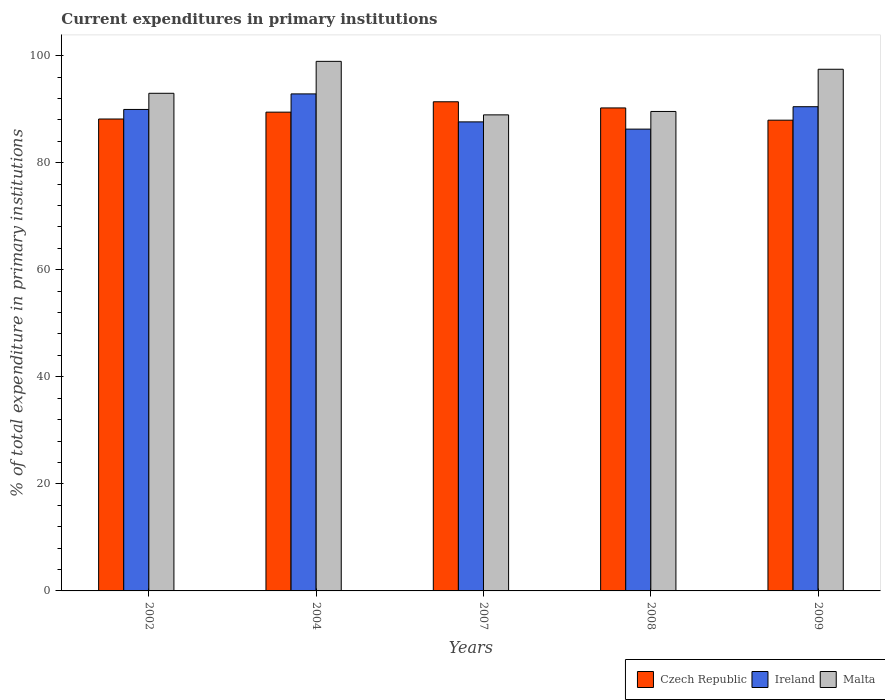How many groups of bars are there?
Give a very brief answer. 5. What is the current expenditures in primary institutions in Ireland in 2004?
Offer a terse response. 92.85. Across all years, what is the maximum current expenditures in primary institutions in Ireland?
Keep it short and to the point. 92.85. Across all years, what is the minimum current expenditures in primary institutions in Ireland?
Ensure brevity in your answer.  86.27. What is the total current expenditures in primary institutions in Ireland in the graph?
Ensure brevity in your answer.  447.14. What is the difference between the current expenditures in primary institutions in Ireland in 2002 and that in 2007?
Your response must be concise. 2.32. What is the difference between the current expenditures in primary institutions in Czech Republic in 2007 and the current expenditures in primary institutions in Malta in 2008?
Keep it short and to the point. 1.81. What is the average current expenditures in primary institutions in Malta per year?
Offer a very short reply. 93.57. In the year 2002, what is the difference between the current expenditures in primary institutions in Malta and current expenditures in primary institutions in Ireland?
Your answer should be compact. 3.02. What is the ratio of the current expenditures in primary institutions in Czech Republic in 2007 to that in 2008?
Provide a short and direct response. 1.01. Is the current expenditures in primary institutions in Czech Republic in 2002 less than that in 2009?
Keep it short and to the point. No. What is the difference between the highest and the second highest current expenditures in primary institutions in Czech Republic?
Your answer should be compact. 1.15. What is the difference between the highest and the lowest current expenditures in primary institutions in Malta?
Offer a very short reply. 10. Is the sum of the current expenditures in primary institutions in Czech Republic in 2004 and 2008 greater than the maximum current expenditures in primary institutions in Malta across all years?
Keep it short and to the point. Yes. What does the 2nd bar from the left in 2007 represents?
Make the answer very short. Ireland. What does the 3rd bar from the right in 2009 represents?
Make the answer very short. Czech Republic. Is it the case that in every year, the sum of the current expenditures in primary institutions in Ireland and current expenditures in primary institutions in Czech Republic is greater than the current expenditures in primary institutions in Malta?
Make the answer very short. Yes. Are all the bars in the graph horizontal?
Ensure brevity in your answer.  No. Are the values on the major ticks of Y-axis written in scientific E-notation?
Your answer should be compact. No. How many legend labels are there?
Give a very brief answer. 3. How are the legend labels stacked?
Provide a short and direct response. Horizontal. What is the title of the graph?
Your answer should be very brief. Current expenditures in primary institutions. Does "Isle of Man" appear as one of the legend labels in the graph?
Provide a short and direct response. No. What is the label or title of the X-axis?
Ensure brevity in your answer.  Years. What is the label or title of the Y-axis?
Provide a succinct answer. % of total expenditure in primary institutions. What is the % of total expenditure in primary institutions in Czech Republic in 2002?
Keep it short and to the point. 88.16. What is the % of total expenditure in primary institutions in Ireland in 2002?
Offer a very short reply. 89.94. What is the % of total expenditure in primary institutions in Malta in 2002?
Make the answer very short. 92.96. What is the % of total expenditure in primary institutions of Czech Republic in 2004?
Provide a succinct answer. 89.44. What is the % of total expenditure in primary institutions in Ireland in 2004?
Offer a terse response. 92.85. What is the % of total expenditure in primary institutions in Malta in 2004?
Offer a very short reply. 98.93. What is the % of total expenditure in primary institutions of Czech Republic in 2007?
Provide a short and direct response. 91.38. What is the % of total expenditure in primary institutions of Ireland in 2007?
Provide a short and direct response. 87.62. What is the % of total expenditure in primary institutions in Malta in 2007?
Provide a succinct answer. 88.93. What is the % of total expenditure in primary institutions of Czech Republic in 2008?
Your answer should be very brief. 90.23. What is the % of total expenditure in primary institutions in Ireland in 2008?
Your answer should be very brief. 86.27. What is the % of total expenditure in primary institutions of Malta in 2008?
Offer a very short reply. 89.57. What is the % of total expenditure in primary institutions in Czech Republic in 2009?
Make the answer very short. 87.94. What is the % of total expenditure in primary institutions of Ireland in 2009?
Provide a succinct answer. 90.46. What is the % of total expenditure in primary institutions in Malta in 2009?
Make the answer very short. 97.45. Across all years, what is the maximum % of total expenditure in primary institutions in Czech Republic?
Offer a very short reply. 91.38. Across all years, what is the maximum % of total expenditure in primary institutions of Ireland?
Keep it short and to the point. 92.85. Across all years, what is the maximum % of total expenditure in primary institutions in Malta?
Make the answer very short. 98.93. Across all years, what is the minimum % of total expenditure in primary institutions in Czech Republic?
Offer a very short reply. 87.94. Across all years, what is the minimum % of total expenditure in primary institutions of Ireland?
Make the answer very short. 86.27. Across all years, what is the minimum % of total expenditure in primary institutions of Malta?
Offer a terse response. 88.93. What is the total % of total expenditure in primary institutions in Czech Republic in the graph?
Provide a succinct answer. 447.15. What is the total % of total expenditure in primary institutions of Ireland in the graph?
Provide a succinct answer. 447.14. What is the total % of total expenditure in primary institutions of Malta in the graph?
Provide a short and direct response. 467.85. What is the difference between the % of total expenditure in primary institutions of Czech Republic in 2002 and that in 2004?
Offer a terse response. -1.28. What is the difference between the % of total expenditure in primary institutions of Ireland in 2002 and that in 2004?
Provide a succinct answer. -2.9. What is the difference between the % of total expenditure in primary institutions in Malta in 2002 and that in 2004?
Ensure brevity in your answer.  -5.96. What is the difference between the % of total expenditure in primary institutions of Czech Republic in 2002 and that in 2007?
Your response must be concise. -3.22. What is the difference between the % of total expenditure in primary institutions in Ireland in 2002 and that in 2007?
Provide a succinct answer. 2.32. What is the difference between the % of total expenditure in primary institutions in Malta in 2002 and that in 2007?
Your answer should be compact. 4.03. What is the difference between the % of total expenditure in primary institutions in Czech Republic in 2002 and that in 2008?
Your answer should be very brief. -2.07. What is the difference between the % of total expenditure in primary institutions in Ireland in 2002 and that in 2008?
Your answer should be compact. 3.68. What is the difference between the % of total expenditure in primary institutions in Malta in 2002 and that in 2008?
Give a very brief answer. 3.39. What is the difference between the % of total expenditure in primary institutions in Czech Republic in 2002 and that in 2009?
Ensure brevity in your answer.  0.22. What is the difference between the % of total expenditure in primary institutions of Ireland in 2002 and that in 2009?
Keep it short and to the point. -0.51. What is the difference between the % of total expenditure in primary institutions in Malta in 2002 and that in 2009?
Give a very brief answer. -4.49. What is the difference between the % of total expenditure in primary institutions of Czech Republic in 2004 and that in 2007?
Provide a short and direct response. -1.94. What is the difference between the % of total expenditure in primary institutions of Ireland in 2004 and that in 2007?
Your answer should be compact. 5.23. What is the difference between the % of total expenditure in primary institutions in Malta in 2004 and that in 2007?
Make the answer very short. 10. What is the difference between the % of total expenditure in primary institutions of Czech Republic in 2004 and that in 2008?
Offer a terse response. -0.79. What is the difference between the % of total expenditure in primary institutions of Ireland in 2004 and that in 2008?
Provide a short and direct response. 6.58. What is the difference between the % of total expenditure in primary institutions in Malta in 2004 and that in 2008?
Give a very brief answer. 9.36. What is the difference between the % of total expenditure in primary institutions in Czech Republic in 2004 and that in 2009?
Your response must be concise. 1.5. What is the difference between the % of total expenditure in primary institutions in Ireland in 2004 and that in 2009?
Your answer should be very brief. 2.39. What is the difference between the % of total expenditure in primary institutions of Malta in 2004 and that in 2009?
Ensure brevity in your answer.  1.48. What is the difference between the % of total expenditure in primary institutions in Czech Republic in 2007 and that in 2008?
Offer a terse response. 1.15. What is the difference between the % of total expenditure in primary institutions of Ireland in 2007 and that in 2008?
Provide a succinct answer. 1.35. What is the difference between the % of total expenditure in primary institutions of Malta in 2007 and that in 2008?
Offer a very short reply. -0.64. What is the difference between the % of total expenditure in primary institutions in Czech Republic in 2007 and that in 2009?
Offer a very short reply. 3.44. What is the difference between the % of total expenditure in primary institutions of Ireland in 2007 and that in 2009?
Offer a very short reply. -2.84. What is the difference between the % of total expenditure in primary institutions of Malta in 2007 and that in 2009?
Provide a succinct answer. -8.52. What is the difference between the % of total expenditure in primary institutions in Czech Republic in 2008 and that in 2009?
Your answer should be compact. 2.29. What is the difference between the % of total expenditure in primary institutions in Ireland in 2008 and that in 2009?
Keep it short and to the point. -4.19. What is the difference between the % of total expenditure in primary institutions in Malta in 2008 and that in 2009?
Offer a terse response. -7.88. What is the difference between the % of total expenditure in primary institutions of Czech Republic in 2002 and the % of total expenditure in primary institutions of Ireland in 2004?
Offer a very short reply. -4.69. What is the difference between the % of total expenditure in primary institutions in Czech Republic in 2002 and the % of total expenditure in primary institutions in Malta in 2004?
Provide a succinct answer. -10.77. What is the difference between the % of total expenditure in primary institutions of Ireland in 2002 and the % of total expenditure in primary institutions of Malta in 2004?
Provide a short and direct response. -8.98. What is the difference between the % of total expenditure in primary institutions in Czech Republic in 2002 and the % of total expenditure in primary institutions in Ireland in 2007?
Ensure brevity in your answer.  0.54. What is the difference between the % of total expenditure in primary institutions of Czech Republic in 2002 and the % of total expenditure in primary institutions of Malta in 2007?
Provide a short and direct response. -0.77. What is the difference between the % of total expenditure in primary institutions in Ireland in 2002 and the % of total expenditure in primary institutions in Malta in 2007?
Offer a very short reply. 1.01. What is the difference between the % of total expenditure in primary institutions of Czech Republic in 2002 and the % of total expenditure in primary institutions of Ireland in 2008?
Provide a short and direct response. 1.89. What is the difference between the % of total expenditure in primary institutions in Czech Republic in 2002 and the % of total expenditure in primary institutions in Malta in 2008?
Your answer should be very brief. -1.41. What is the difference between the % of total expenditure in primary institutions in Ireland in 2002 and the % of total expenditure in primary institutions in Malta in 2008?
Provide a short and direct response. 0.38. What is the difference between the % of total expenditure in primary institutions of Czech Republic in 2002 and the % of total expenditure in primary institutions of Ireland in 2009?
Give a very brief answer. -2.3. What is the difference between the % of total expenditure in primary institutions in Czech Republic in 2002 and the % of total expenditure in primary institutions in Malta in 2009?
Give a very brief answer. -9.29. What is the difference between the % of total expenditure in primary institutions in Ireland in 2002 and the % of total expenditure in primary institutions in Malta in 2009?
Provide a short and direct response. -7.51. What is the difference between the % of total expenditure in primary institutions in Czech Republic in 2004 and the % of total expenditure in primary institutions in Ireland in 2007?
Offer a terse response. 1.82. What is the difference between the % of total expenditure in primary institutions in Czech Republic in 2004 and the % of total expenditure in primary institutions in Malta in 2007?
Keep it short and to the point. 0.51. What is the difference between the % of total expenditure in primary institutions of Ireland in 2004 and the % of total expenditure in primary institutions of Malta in 2007?
Offer a very short reply. 3.92. What is the difference between the % of total expenditure in primary institutions of Czech Republic in 2004 and the % of total expenditure in primary institutions of Ireland in 2008?
Keep it short and to the point. 3.17. What is the difference between the % of total expenditure in primary institutions in Czech Republic in 2004 and the % of total expenditure in primary institutions in Malta in 2008?
Your answer should be very brief. -0.13. What is the difference between the % of total expenditure in primary institutions of Ireland in 2004 and the % of total expenditure in primary institutions of Malta in 2008?
Your answer should be very brief. 3.28. What is the difference between the % of total expenditure in primary institutions of Czech Republic in 2004 and the % of total expenditure in primary institutions of Ireland in 2009?
Your answer should be very brief. -1.02. What is the difference between the % of total expenditure in primary institutions in Czech Republic in 2004 and the % of total expenditure in primary institutions in Malta in 2009?
Your response must be concise. -8.01. What is the difference between the % of total expenditure in primary institutions of Ireland in 2004 and the % of total expenditure in primary institutions of Malta in 2009?
Offer a terse response. -4.6. What is the difference between the % of total expenditure in primary institutions in Czech Republic in 2007 and the % of total expenditure in primary institutions in Ireland in 2008?
Provide a short and direct response. 5.11. What is the difference between the % of total expenditure in primary institutions of Czech Republic in 2007 and the % of total expenditure in primary institutions of Malta in 2008?
Your response must be concise. 1.81. What is the difference between the % of total expenditure in primary institutions in Ireland in 2007 and the % of total expenditure in primary institutions in Malta in 2008?
Ensure brevity in your answer.  -1.95. What is the difference between the % of total expenditure in primary institutions of Czech Republic in 2007 and the % of total expenditure in primary institutions of Ireland in 2009?
Your answer should be very brief. 0.92. What is the difference between the % of total expenditure in primary institutions of Czech Republic in 2007 and the % of total expenditure in primary institutions of Malta in 2009?
Your answer should be compact. -6.07. What is the difference between the % of total expenditure in primary institutions of Ireland in 2007 and the % of total expenditure in primary institutions of Malta in 2009?
Ensure brevity in your answer.  -9.83. What is the difference between the % of total expenditure in primary institutions in Czech Republic in 2008 and the % of total expenditure in primary institutions in Ireland in 2009?
Make the answer very short. -0.23. What is the difference between the % of total expenditure in primary institutions in Czech Republic in 2008 and the % of total expenditure in primary institutions in Malta in 2009?
Ensure brevity in your answer.  -7.22. What is the difference between the % of total expenditure in primary institutions of Ireland in 2008 and the % of total expenditure in primary institutions of Malta in 2009?
Your response must be concise. -11.18. What is the average % of total expenditure in primary institutions in Czech Republic per year?
Your response must be concise. 89.43. What is the average % of total expenditure in primary institutions of Ireland per year?
Your answer should be very brief. 89.43. What is the average % of total expenditure in primary institutions in Malta per year?
Your answer should be compact. 93.57. In the year 2002, what is the difference between the % of total expenditure in primary institutions of Czech Republic and % of total expenditure in primary institutions of Ireland?
Your answer should be very brief. -1.79. In the year 2002, what is the difference between the % of total expenditure in primary institutions of Czech Republic and % of total expenditure in primary institutions of Malta?
Offer a very short reply. -4.8. In the year 2002, what is the difference between the % of total expenditure in primary institutions of Ireland and % of total expenditure in primary institutions of Malta?
Offer a very short reply. -3.02. In the year 2004, what is the difference between the % of total expenditure in primary institutions of Czech Republic and % of total expenditure in primary institutions of Ireland?
Offer a terse response. -3.41. In the year 2004, what is the difference between the % of total expenditure in primary institutions of Czech Republic and % of total expenditure in primary institutions of Malta?
Make the answer very short. -9.49. In the year 2004, what is the difference between the % of total expenditure in primary institutions in Ireland and % of total expenditure in primary institutions in Malta?
Your answer should be compact. -6.08. In the year 2007, what is the difference between the % of total expenditure in primary institutions in Czech Republic and % of total expenditure in primary institutions in Ireland?
Make the answer very short. 3.76. In the year 2007, what is the difference between the % of total expenditure in primary institutions of Czech Republic and % of total expenditure in primary institutions of Malta?
Make the answer very short. 2.45. In the year 2007, what is the difference between the % of total expenditure in primary institutions in Ireland and % of total expenditure in primary institutions in Malta?
Your response must be concise. -1.31. In the year 2008, what is the difference between the % of total expenditure in primary institutions in Czech Republic and % of total expenditure in primary institutions in Ireland?
Give a very brief answer. 3.96. In the year 2008, what is the difference between the % of total expenditure in primary institutions of Czech Republic and % of total expenditure in primary institutions of Malta?
Your answer should be compact. 0.66. In the year 2008, what is the difference between the % of total expenditure in primary institutions of Ireland and % of total expenditure in primary institutions of Malta?
Provide a short and direct response. -3.3. In the year 2009, what is the difference between the % of total expenditure in primary institutions in Czech Republic and % of total expenditure in primary institutions in Ireland?
Ensure brevity in your answer.  -2.52. In the year 2009, what is the difference between the % of total expenditure in primary institutions of Czech Republic and % of total expenditure in primary institutions of Malta?
Keep it short and to the point. -9.51. In the year 2009, what is the difference between the % of total expenditure in primary institutions of Ireland and % of total expenditure in primary institutions of Malta?
Give a very brief answer. -7. What is the ratio of the % of total expenditure in primary institutions in Czech Republic in 2002 to that in 2004?
Make the answer very short. 0.99. What is the ratio of the % of total expenditure in primary institutions of Ireland in 2002 to that in 2004?
Your answer should be compact. 0.97. What is the ratio of the % of total expenditure in primary institutions in Malta in 2002 to that in 2004?
Your response must be concise. 0.94. What is the ratio of the % of total expenditure in primary institutions of Czech Republic in 2002 to that in 2007?
Provide a short and direct response. 0.96. What is the ratio of the % of total expenditure in primary institutions in Ireland in 2002 to that in 2007?
Your response must be concise. 1.03. What is the ratio of the % of total expenditure in primary institutions in Malta in 2002 to that in 2007?
Offer a terse response. 1.05. What is the ratio of the % of total expenditure in primary institutions in Czech Republic in 2002 to that in 2008?
Make the answer very short. 0.98. What is the ratio of the % of total expenditure in primary institutions in Ireland in 2002 to that in 2008?
Make the answer very short. 1.04. What is the ratio of the % of total expenditure in primary institutions of Malta in 2002 to that in 2008?
Your answer should be very brief. 1.04. What is the ratio of the % of total expenditure in primary institutions of Ireland in 2002 to that in 2009?
Provide a short and direct response. 0.99. What is the ratio of the % of total expenditure in primary institutions in Malta in 2002 to that in 2009?
Ensure brevity in your answer.  0.95. What is the ratio of the % of total expenditure in primary institutions of Czech Republic in 2004 to that in 2007?
Offer a very short reply. 0.98. What is the ratio of the % of total expenditure in primary institutions of Ireland in 2004 to that in 2007?
Give a very brief answer. 1.06. What is the ratio of the % of total expenditure in primary institutions of Malta in 2004 to that in 2007?
Provide a succinct answer. 1.11. What is the ratio of the % of total expenditure in primary institutions of Ireland in 2004 to that in 2008?
Provide a short and direct response. 1.08. What is the ratio of the % of total expenditure in primary institutions of Malta in 2004 to that in 2008?
Offer a very short reply. 1.1. What is the ratio of the % of total expenditure in primary institutions of Czech Republic in 2004 to that in 2009?
Your answer should be compact. 1.02. What is the ratio of the % of total expenditure in primary institutions of Ireland in 2004 to that in 2009?
Provide a succinct answer. 1.03. What is the ratio of the % of total expenditure in primary institutions in Malta in 2004 to that in 2009?
Make the answer very short. 1.02. What is the ratio of the % of total expenditure in primary institutions in Czech Republic in 2007 to that in 2008?
Keep it short and to the point. 1.01. What is the ratio of the % of total expenditure in primary institutions of Ireland in 2007 to that in 2008?
Your answer should be compact. 1.02. What is the ratio of the % of total expenditure in primary institutions of Malta in 2007 to that in 2008?
Give a very brief answer. 0.99. What is the ratio of the % of total expenditure in primary institutions of Czech Republic in 2007 to that in 2009?
Offer a terse response. 1.04. What is the ratio of the % of total expenditure in primary institutions of Ireland in 2007 to that in 2009?
Your answer should be compact. 0.97. What is the ratio of the % of total expenditure in primary institutions of Malta in 2007 to that in 2009?
Provide a short and direct response. 0.91. What is the ratio of the % of total expenditure in primary institutions in Ireland in 2008 to that in 2009?
Your answer should be compact. 0.95. What is the ratio of the % of total expenditure in primary institutions in Malta in 2008 to that in 2009?
Make the answer very short. 0.92. What is the difference between the highest and the second highest % of total expenditure in primary institutions in Czech Republic?
Ensure brevity in your answer.  1.15. What is the difference between the highest and the second highest % of total expenditure in primary institutions in Ireland?
Offer a terse response. 2.39. What is the difference between the highest and the second highest % of total expenditure in primary institutions in Malta?
Give a very brief answer. 1.48. What is the difference between the highest and the lowest % of total expenditure in primary institutions in Czech Republic?
Give a very brief answer. 3.44. What is the difference between the highest and the lowest % of total expenditure in primary institutions of Ireland?
Provide a succinct answer. 6.58. What is the difference between the highest and the lowest % of total expenditure in primary institutions of Malta?
Provide a succinct answer. 10. 